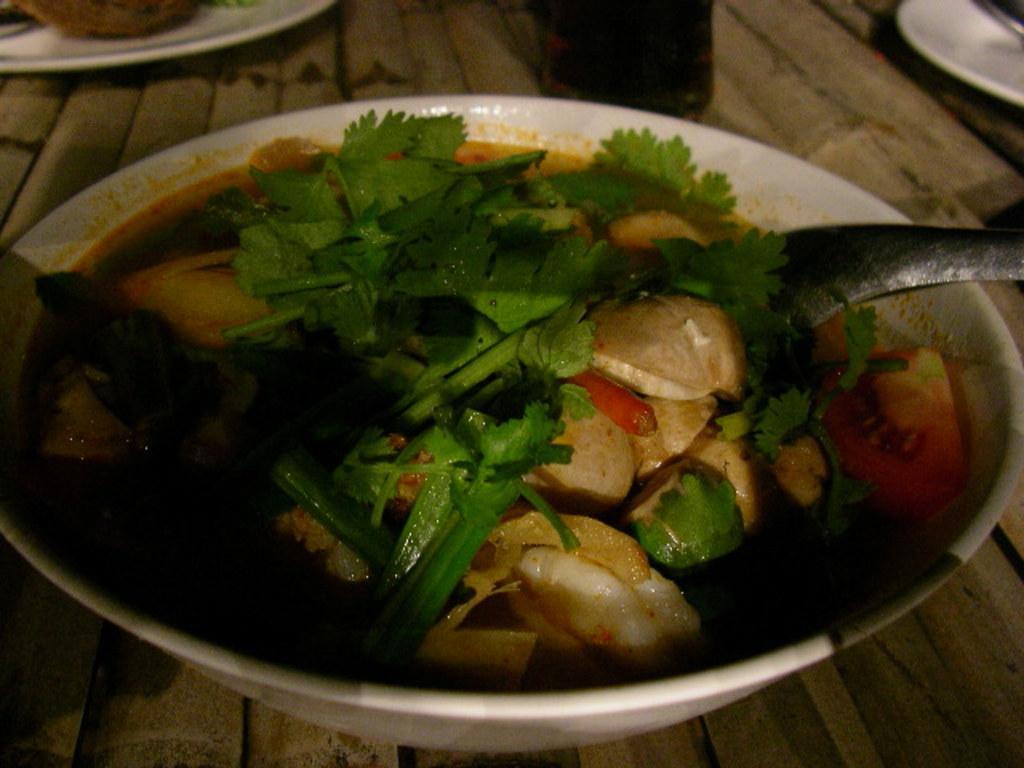How would you summarize this image in a sentence or two? In this image at the bottom there is one table, on the table there is one bowl. In that bowl there are some food items and one spoon and in the background there are some plates. 